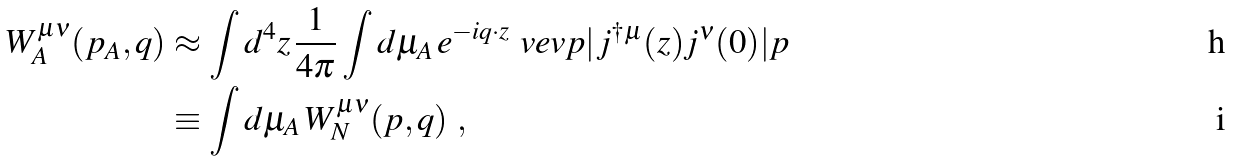Convert formula to latex. <formula><loc_0><loc_0><loc_500><loc_500>W _ { A } ^ { \mu \nu } ( p _ { A } , q ) & \approx \int d ^ { 4 } z \, \frac { 1 } { 4 \pi } \int d \mu _ { A } \, e ^ { - i q \cdot z } \ v e v { p | j ^ { \dagger \mu } ( z ) j ^ { \nu } ( 0 ) | p } \\ & \equiv \int d \mu _ { A } \, W _ { N } ^ { \mu \nu } ( p , q ) \ ,</formula> 